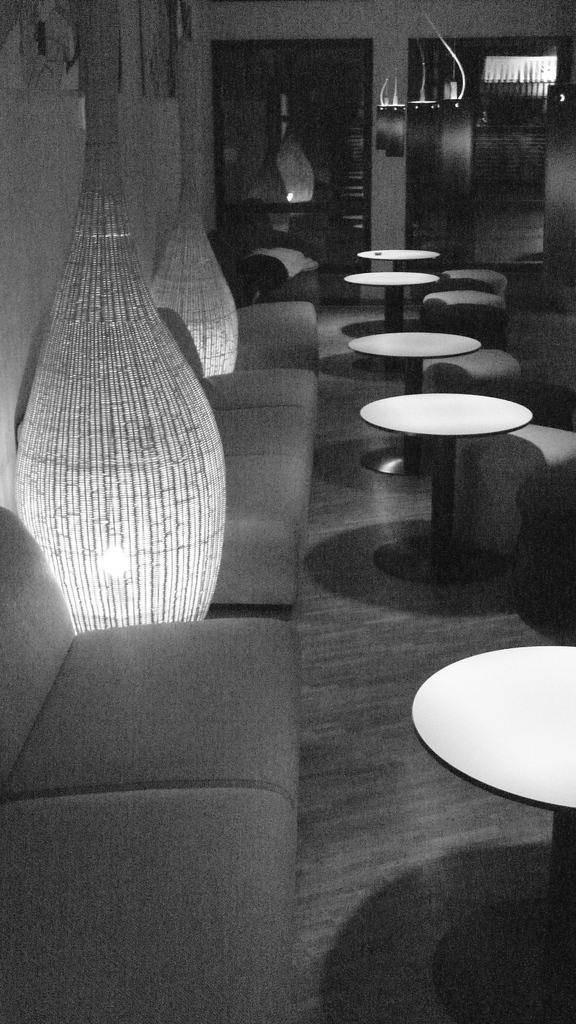Can you describe this image briefly? In this image I can see sofas, tables, wall and some other objects on the floor. This image is black and white in color. 